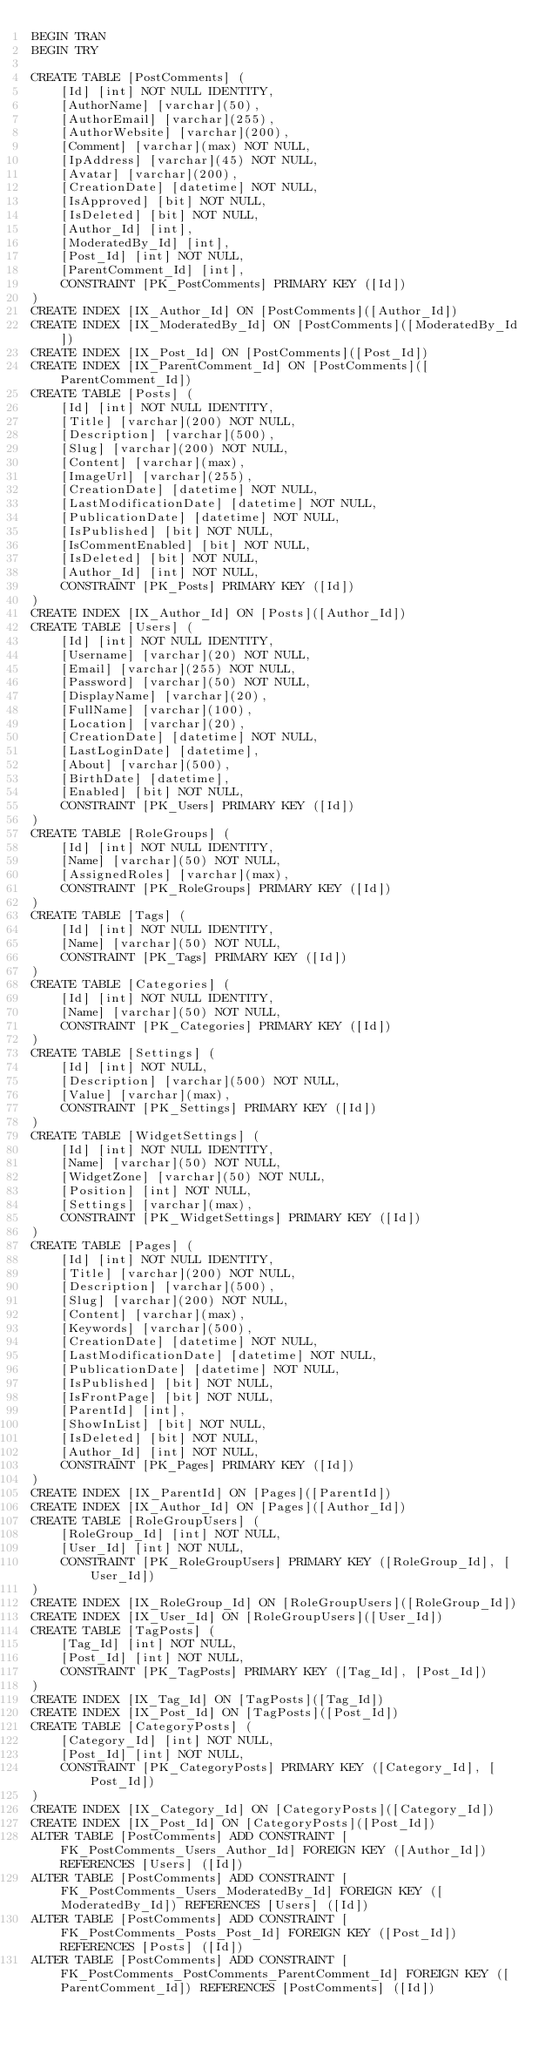Convert code to text. <code><loc_0><loc_0><loc_500><loc_500><_SQL_>BEGIN TRAN
BEGIN TRY

CREATE TABLE [PostComments] (
    [Id] [int] NOT NULL IDENTITY,
    [AuthorName] [varchar](50),
    [AuthorEmail] [varchar](255),
    [AuthorWebsite] [varchar](200),
    [Comment] [varchar](max) NOT NULL,
    [IpAddress] [varchar](45) NOT NULL,
    [Avatar] [varchar](200),
    [CreationDate] [datetime] NOT NULL,
    [IsApproved] [bit] NOT NULL,
    [IsDeleted] [bit] NOT NULL,
    [Author_Id] [int],
    [ModeratedBy_Id] [int],
    [Post_Id] [int] NOT NULL,
    [ParentComment_Id] [int],
    CONSTRAINT [PK_PostComments] PRIMARY KEY ([Id])
)
CREATE INDEX [IX_Author_Id] ON [PostComments]([Author_Id])
CREATE INDEX [IX_ModeratedBy_Id] ON [PostComments]([ModeratedBy_Id])
CREATE INDEX [IX_Post_Id] ON [PostComments]([Post_Id])
CREATE INDEX [IX_ParentComment_Id] ON [PostComments]([ParentComment_Id])
CREATE TABLE [Posts] (
    [Id] [int] NOT NULL IDENTITY,
    [Title] [varchar](200) NOT NULL,
    [Description] [varchar](500),
    [Slug] [varchar](200) NOT NULL,
    [Content] [varchar](max),
    [ImageUrl] [varchar](255),
    [CreationDate] [datetime] NOT NULL,
    [LastModificationDate] [datetime] NOT NULL,
    [PublicationDate] [datetime] NOT NULL,
    [IsPublished] [bit] NOT NULL,
    [IsCommentEnabled] [bit] NOT NULL,
    [IsDeleted] [bit] NOT NULL,
    [Author_Id] [int] NOT NULL,
    CONSTRAINT [PK_Posts] PRIMARY KEY ([Id])
)
CREATE INDEX [IX_Author_Id] ON [Posts]([Author_Id])
CREATE TABLE [Users] (
    [Id] [int] NOT NULL IDENTITY,
    [Username] [varchar](20) NOT NULL,
    [Email] [varchar](255) NOT NULL,
    [Password] [varchar](50) NOT NULL,
    [DisplayName] [varchar](20),
    [FullName] [varchar](100),
    [Location] [varchar](20),
    [CreationDate] [datetime] NOT NULL,
    [LastLoginDate] [datetime],
    [About] [varchar](500),
    [BirthDate] [datetime],
    [Enabled] [bit] NOT NULL,
    CONSTRAINT [PK_Users] PRIMARY KEY ([Id])
)
CREATE TABLE [RoleGroups] (
    [Id] [int] NOT NULL IDENTITY,
    [Name] [varchar](50) NOT NULL,
    [AssignedRoles] [varchar](max),
    CONSTRAINT [PK_RoleGroups] PRIMARY KEY ([Id])
)
CREATE TABLE [Tags] (
    [Id] [int] NOT NULL IDENTITY,
    [Name] [varchar](50) NOT NULL,
    CONSTRAINT [PK_Tags] PRIMARY KEY ([Id])
)
CREATE TABLE [Categories] (
    [Id] [int] NOT NULL IDENTITY,
    [Name] [varchar](50) NOT NULL,
    CONSTRAINT [PK_Categories] PRIMARY KEY ([Id])
)
CREATE TABLE [Settings] (
    [Id] [int] NOT NULL,
    [Description] [varchar](500) NOT NULL,
    [Value] [varchar](max),
    CONSTRAINT [PK_Settings] PRIMARY KEY ([Id])
)
CREATE TABLE [WidgetSettings] (
    [Id] [int] NOT NULL IDENTITY,
    [Name] [varchar](50) NOT NULL,
    [WidgetZone] [varchar](50) NOT NULL,
    [Position] [int] NOT NULL,
    [Settings] [varchar](max),
    CONSTRAINT [PK_WidgetSettings] PRIMARY KEY ([Id])
)
CREATE TABLE [Pages] (
    [Id] [int] NOT NULL IDENTITY,
    [Title] [varchar](200) NOT NULL,
    [Description] [varchar](500),
    [Slug] [varchar](200) NOT NULL,
    [Content] [varchar](max),
    [Keywords] [varchar](500),
    [CreationDate] [datetime] NOT NULL,
    [LastModificationDate] [datetime] NOT NULL,
    [PublicationDate] [datetime] NOT NULL,
    [IsPublished] [bit] NOT NULL,
    [IsFrontPage] [bit] NOT NULL,
    [ParentId] [int],
    [ShowInList] [bit] NOT NULL,
    [IsDeleted] [bit] NOT NULL,
    [Author_Id] [int] NOT NULL,
    CONSTRAINT [PK_Pages] PRIMARY KEY ([Id])
)
CREATE INDEX [IX_ParentId] ON [Pages]([ParentId])
CREATE INDEX [IX_Author_Id] ON [Pages]([Author_Id])
CREATE TABLE [RoleGroupUsers] (
    [RoleGroup_Id] [int] NOT NULL,
    [User_Id] [int] NOT NULL,
    CONSTRAINT [PK_RoleGroupUsers] PRIMARY KEY ([RoleGroup_Id], [User_Id])
)
CREATE INDEX [IX_RoleGroup_Id] ON [RoleGroupUsers]([RoleGroup_Id])
CREATE INDEX [IX_User_Id] ON [RoleGroupUsers]([User_Id])
CREATE TABLE [TagPosts] (
    [Tag_Id] [int] NOT NULL,
    [Post_Id] [int] NOT NULL,
    CONSTRAINT [PK_TagPosts] PRIMARY KEY ([Tag_Id], [Post_Id])
)
CREATE INDEX [IX_Tag_Id] ON [TagPosts]([Tag_Id])
CREATE INDEX [IX_Post_Id] ON [TagPosts]([Post_Id])
CREATE TABLE [CategoryPosts] (
    [Category_Id] [int] NOT NULL,
    [Post_Id] [int] NOT NULL,
    CONSTRAINT [PK_CategoryPosts] PRIMARY KEY ([Category_Id], [Post_Id])
)
CREATE INDEX [IX_Category_Id] ON [CategoryPosts]([Category_Id])
CREATE INDEX [IX_Post_Id] ON [CategoryPosts]([Post_Id])
ALTER TABLE [PostComments] ADD CONSTRAINT [FK_PostComments_Users_Author_Id] FOREIGN KEY ([Author_Id]) REFERENCES [Users] ([Id])
ALTER TABLE [PostComments] ADD CONSTRAINT [FK_PostComments_Users_ModeratedBy_Id] FOREIGN KEY ([ModeratedBy_Id]) REFERENCES [Users] ([Id])
ALTER TABLE [PostComments] ADD CONSTRAINT [FK_PostComments_Posts_Post_Id] FOREIGN KEY ([Post_Id]) REFERENCES [Posts] ([Id])
ALTER TABLE [PostComments] ADD CONSTRAINT [FK_PostComments_PostComments_ParentComment_Id] FOREIGN KEY ([ParentComment_Id]) REFERENCES [PostComments] ([Id])</code> 